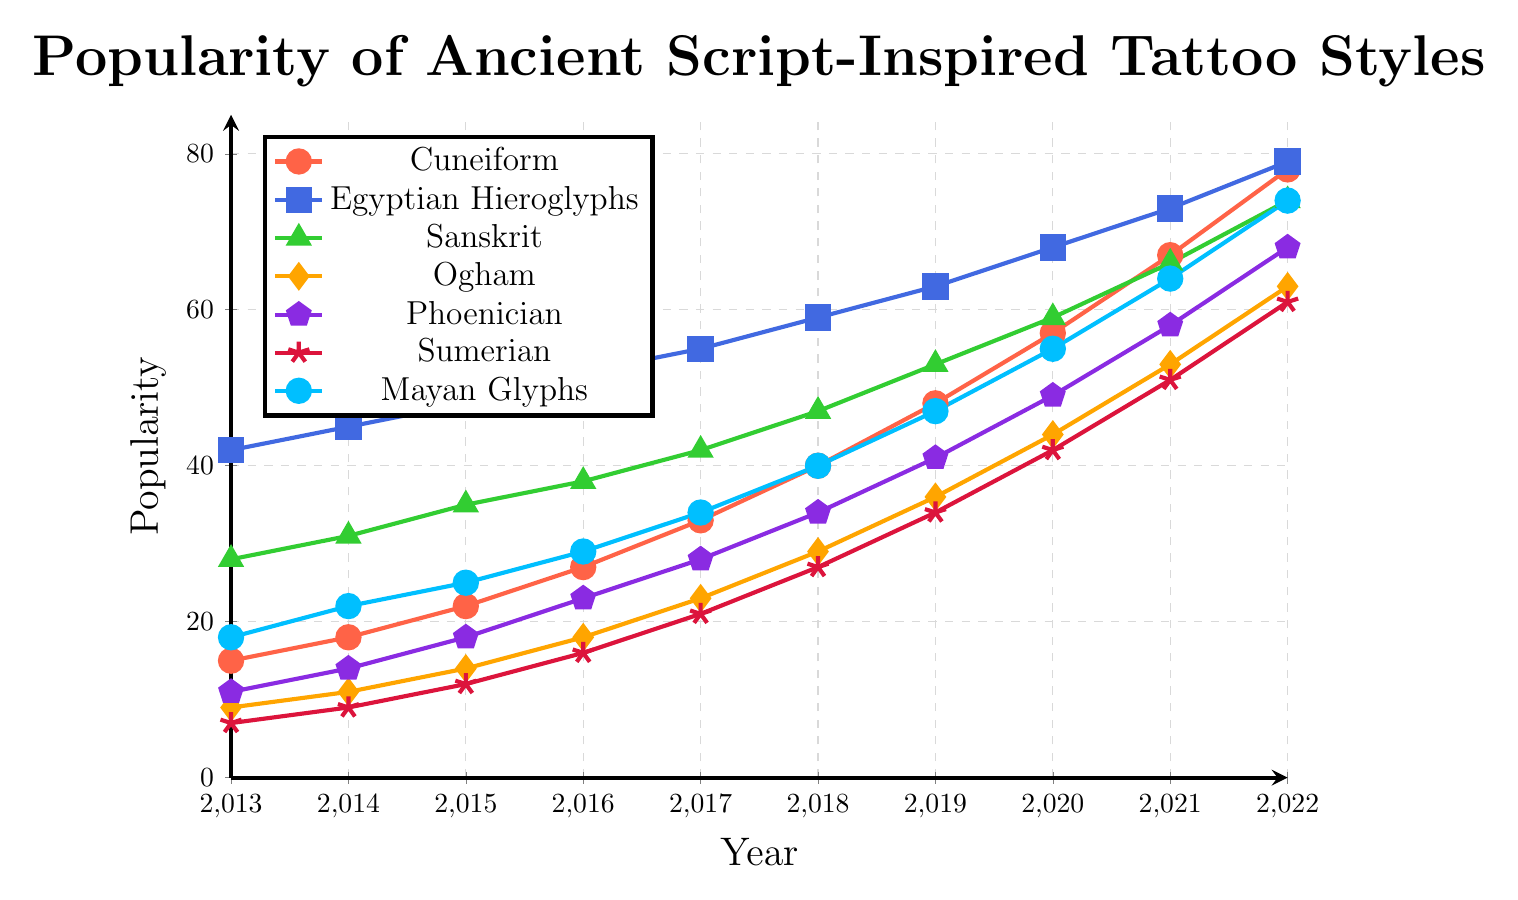Which ancient script-inspired tattoo style had the highest popularity in 2022? According to the graph, Egyptian Hieroglyphs exhibit the highest popularity in 2022, reaching a value of 79.
Answer: Egyptian Hieroglyphs Which style had the lowest popularity in 2013? The graph shows that in 2013, Sumerian tattoos had the lowest popularity with a value of 7.
Answer: Sumerian How did the popularity of Ogham tattoos change between 2016 and 2022? The popularity of Ogham increased from 18 in 2016 to 63 in 2022. The difference is calculated as 63 - 18 = 45.
Answer: Increased by 45 Compare the popularity trends of Cuneiform and Sanskrit tattoos from 2013 to 2022. Which was more popular in 2019, and by how much? In 2019, the popularity of Cuneiform was 48 and Sanskrit was 53. Sanskrit tattoos were more popular in 2019 by 53 - 48 = 5.
Answer: Sanskrit by 5 What was the approximate average popularity of Phoenician tattoos over the decade? The values from 2013 to 2022 are 11, 14, 18, 23, 28, 34, 41, 49, 58, 68. Summing these gives 344. Dividing by 10 (number of years) gives 34.4.
Answer: Approximately 34.4 Which tattoo style showed the most substantial increase in popularity from 2013 to 2022? To determine this, we calculate the difference for each style from 2013 to 2022 and find the maximum:
- Cuneiform: 78 - 15 = 63
- Egyptian Hieroglyphs: 79 - 42 = 37
- Sanskrit: 74 - 28 = 46
- Ogham: 63 - 9 = 54
- Phoenician: 68 - 11 = 57
- Sumerian: 61 - 7 = 54
- Mayan Glyphs: 74 - 18 = 56
Cuneiform shows the largest increase.
Answer: Cuneiform What is the visual color representation used for Mayan Glyphs in the plot? The plot shows Mayan Glyphs marked with a circular symbol and colored in blue.
Answer: Blue with circular marks If the popularity trends continue, which style is likely to reach or exceed a popularity of 100 first? Based on the trends, Egyptian Hieroglyphs had the highest popularity increase overall and reached 79 by 2022, indicating it is most likely to reach 100 first if trends continue.
Answer: Egyptian Hieroglyphs How many years did it take for Sumerian tattoos to more than double in popularity from their 2013 value? Sumerian tattoos had a popularity of 7 in 2013. Doubling this gives 14. They reached or exceeded this in 2016 with a value of 16. The difference is 2016 - 2013 = 3 years.
Answer: 3 years 